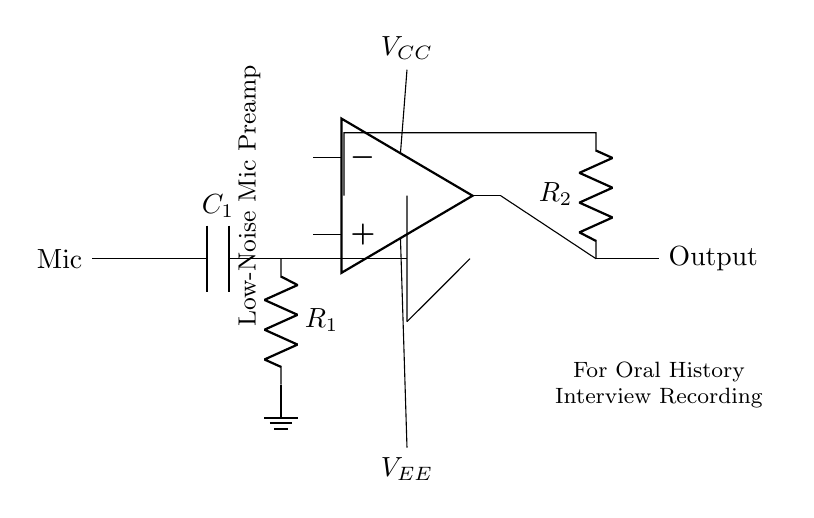What type of component is shown as the input? The input component is a microphone. It's the first element in the circuit, indicated by the label "Mic."
Answer: Microphone What is the function of capacitor C1? Capacitor C1 is used for coupling, blocking any DC component and allowing AC signals (audio) from the microphone to pass through to the next stage.
Answer: Coupling What does R2 in the feedback network do? Resistor R2 sets the gain of the operational amplifier circuit, influencing how much the signal is amplified before output.
Answer: Sets gain What are the voltage supply labels in the circuit? The voltage supplies in the circuit are labeled as VCC and VEE. VCC is for the positive supply, and VEE is for the negative supply.
Answer: VCC and VEE How does the circuit affect noise levels? This circuit is designed as a low-noise microphone preamp, which means it uses high-quality components to minimize noise, providing a clean signal for recording.
Answer: Low-noise What is the output type of this amplifier circuit? The output of the amplifier circuit is a signal voltage, which can be further processed or recorded after amplification.
Answer: Signal voltage What is the overall purpose of this circuit? The overall purpose of this circuit is to amplify the audio signal from a microphone for recording oral history interviews, ensuring clarity and detail in the audio.
Answer: Amplification for recording 